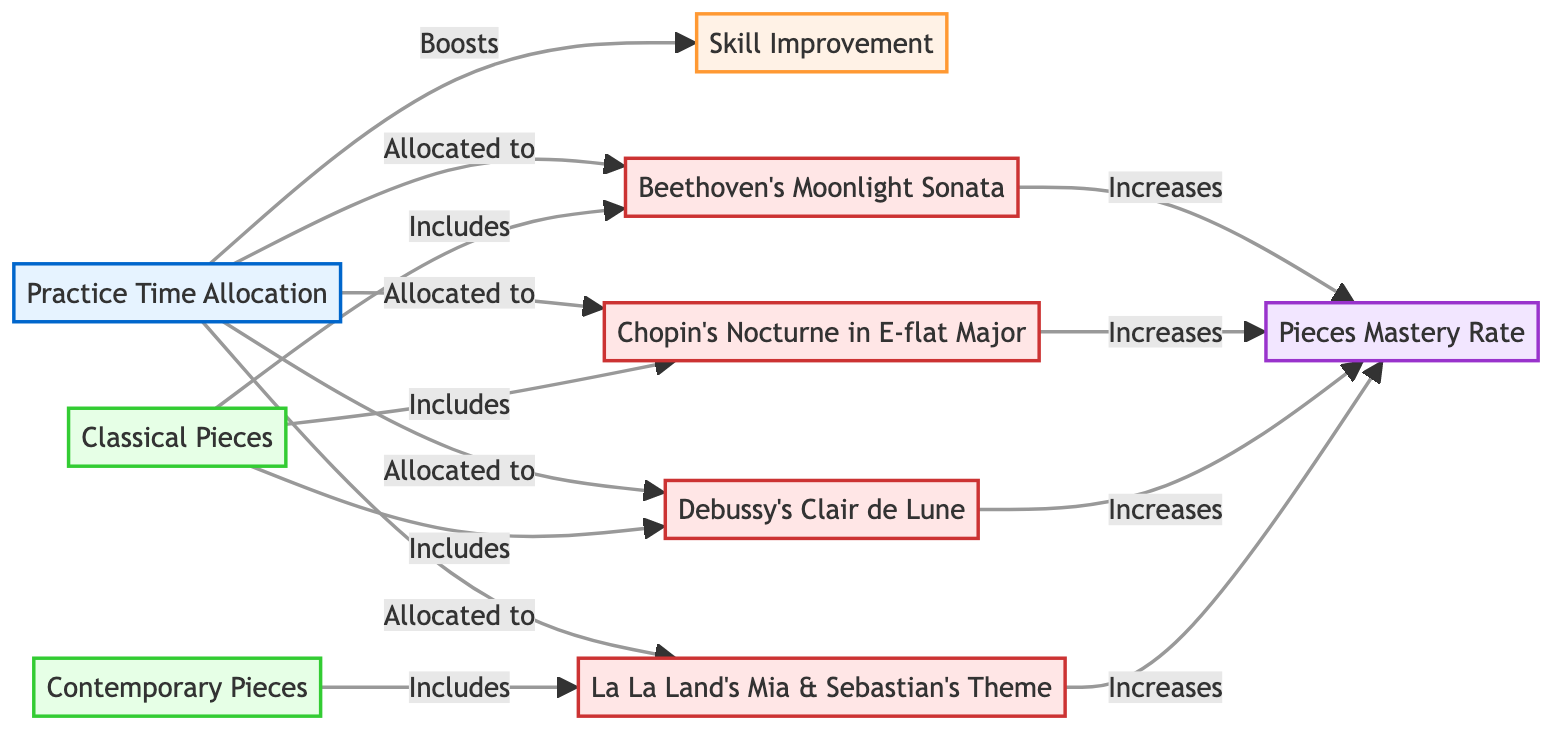What's the total number of nodes in the diagram? The diagram contains 9 distinct nodes, which are Practice Time Allocation, Skill Improvement, Classical Pieces, Contemporary Pieces, Beethoven's Moonlight Sonata, Chopin's Nocturne in E-flat Major, Debussy's Clair de Lune, La La Land's Mia & Sebastian's Theme, and Pieces Mastery Rate.
Answer: 9 What is allocated to Practice Time Allocation? There are four pieces allocated to Practice Time Allocation: Beethoven's Moonlight Sonata, Chopin's Nocturne in E-flat Major, Debussy's Clair de Lune, and La La Land's Mia & Sebastian's Theme.
Answer: Beethoven's Moonlight Sonata, Chopin's Nocturne in E-flat Major, Debussy's Clair de Lune, La La Land's Mia & Sebastian's Theme Which type of pieces increases Pieces Mastery Rate? The pieces that increase Pieces Mastery Rate are Beethoven's Moonlight Sonata, Chopin's Nocturne in E-flat Major, Debussy's Clair de Lune, and La La Land's Mia & Sebastian's Theme.
Answer: Beethoven's Moonlight Sonata, Chopin's Nocturne in E-flat Major, Debussy's Clair de Lune, La La Land's Mia & Sebastian's Theme How many edges connect to Skill Improvement? There is 1 edge that connects to Skill Improvement, indicating that Practice Time Allocation boosts Skill Improvement.
Answer: 1 Does Classical Pieces include La La Land's Mia & Sebastian's Theme? No, Classical Pieces does not include La La Land's Mia & Sebastian's Theme, as it is categorized under Contemporary Pieces.
Answer: No Which category does Chopin's Nocturne in E-flat Major belong to? Chopin's Nocturne in E-flat Major falls under the category of Classical Pieces.
Answer: Classical Pieces Explain how Practice Time Allocation affects Skill Improvement. Practice Time Allocation has a direct relationship that shows it boosts Skill Improvement, illustrating that effective practice contributes positively to skill enhancement.
Answer: Boosts Which piece belongs to the genre Contemporary Pieces? The piece La La Land's Mia & Sebastian's Theme belongs to the genre Contemporary Pieces.
Answer: La La Land's Mia & Sebastian's Theme 